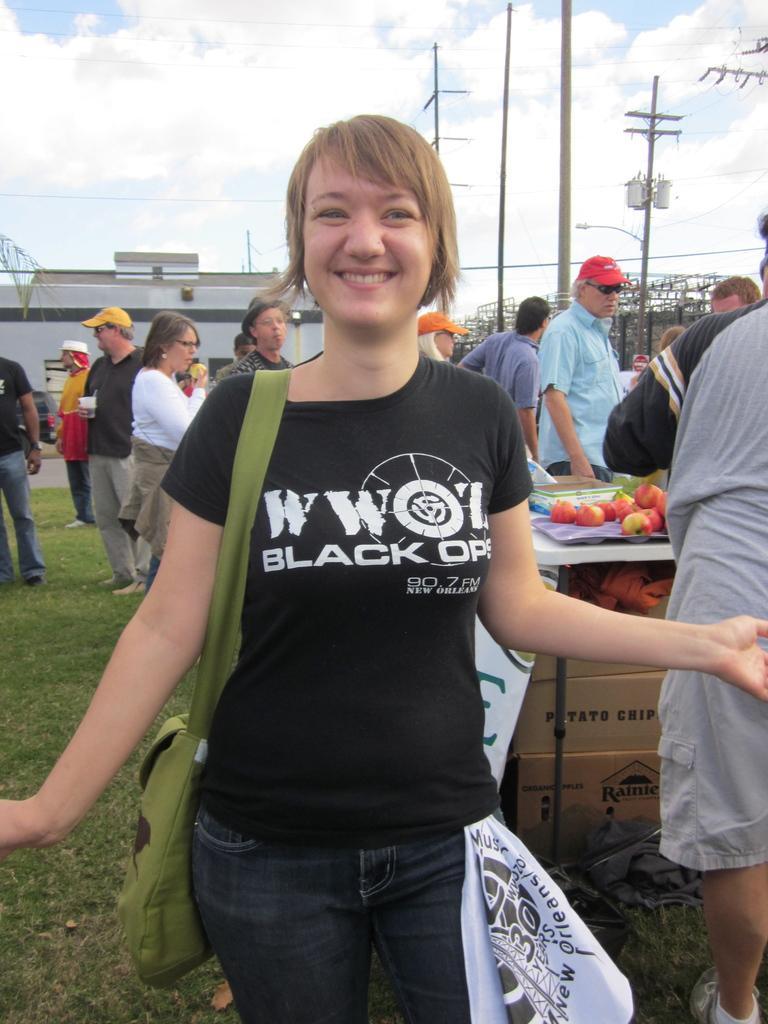Could you give a brief overview of what you see in this image? In this image, we can see a woman is smiling and wearing a bag. Here we can see white cloth. Background there are so many people. Few are holding some objects. Here we can see few carton boxes, table, some items. Here there is a wall, poles, light. Top of the image, we can see a cloudy sky. 